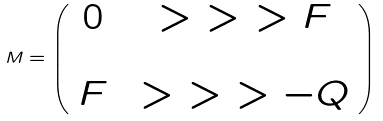Convert formula to latex. <formula><loc_0><loc_0><loc_500><loc_500>M = \left ( \begin{array} { c c } 0 & \ > \ > \ > F \\ \\ F & \ > \ > \ > - Q \end{array} \right )</formula> 